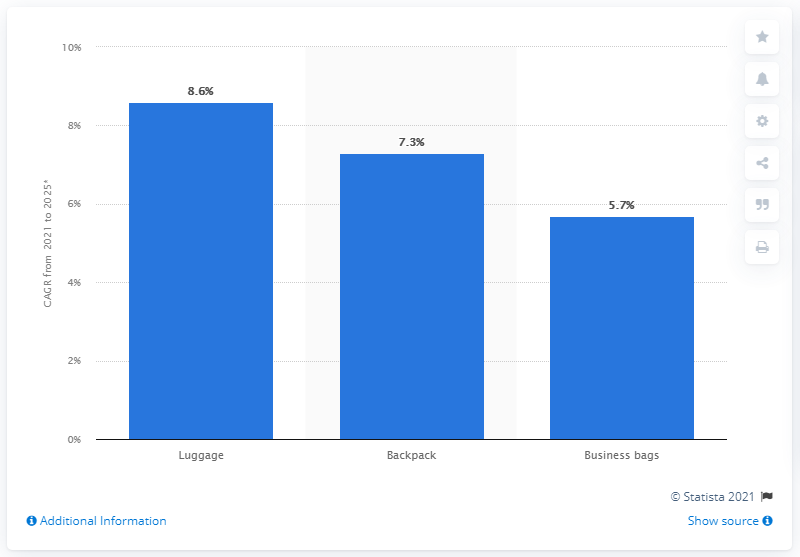Draw attention to some important aspects in this diagram. The backpack luggage retail market is expected to experience a growth rate of approximately 7.3% between 2021 and 2025. 